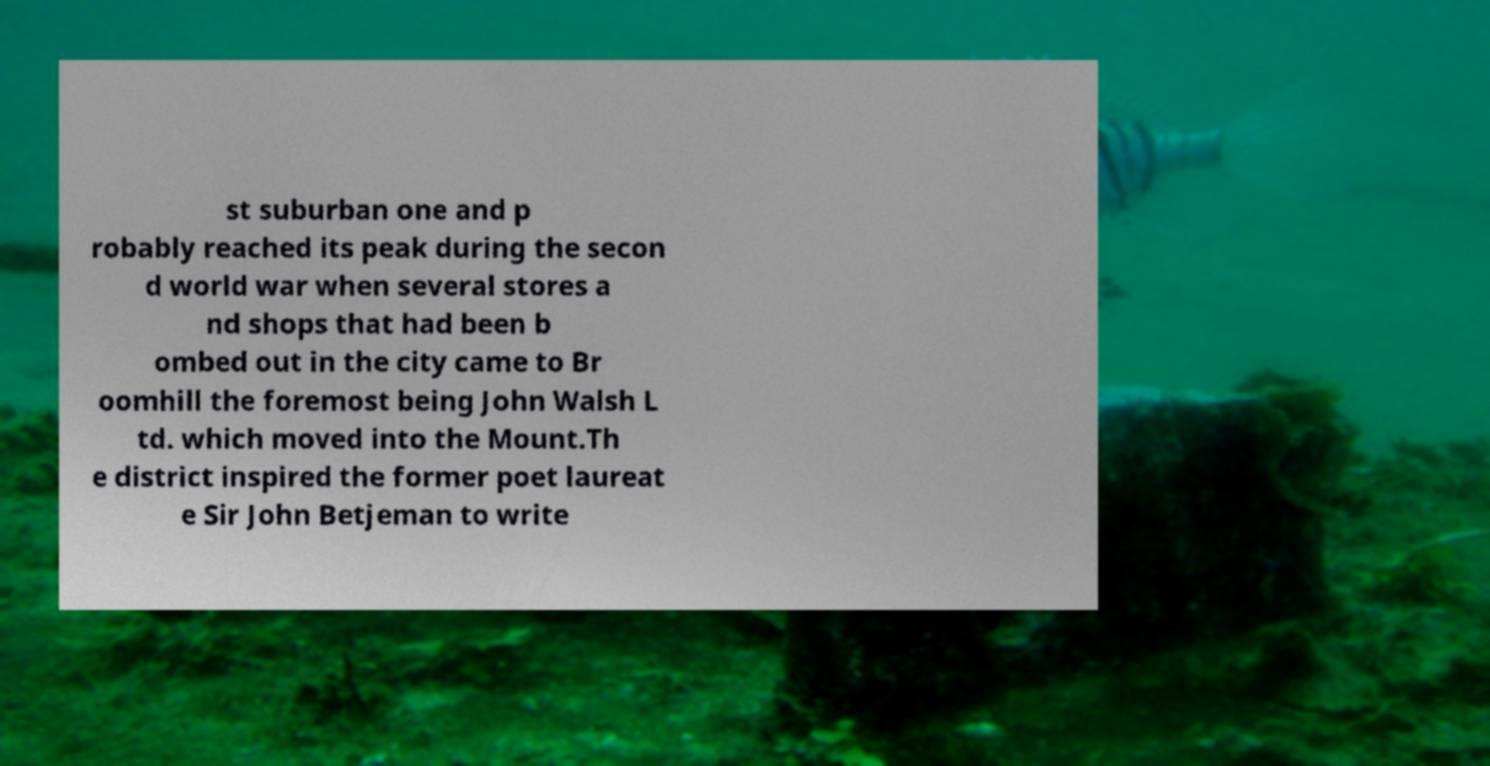Please read and relay the text visible in this image. What does it say? st suburban one and p robably reached its peak during the secon d world war when several stores a nd shops that had been b ombed out in the city came to Br oomhill the foremost being John Walsh L td. which moved into the Mount.Th e district inspired the former poet laureat e Sir John Betjeman to write 